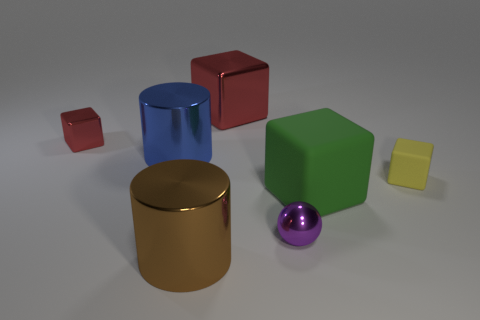Subtract all brown blocks. Subtract all purple spheres. How many blocks are left? 4 Add 1 tiny green things. How many objects exist? 8 Subtract all cubes. How many objects are left? 3 Subtract all large green rubber spheres. Subtract all brown shiny cylinders. How many objects are left? 6 Add 6 blue metallic objects. How many blue metallic objects are left? 7 Add 3 large cyan rubber cubes. How many large cyan rubber cubes exist? 3 Subtract 0 cyan cylinders. How many objects are left? 7 